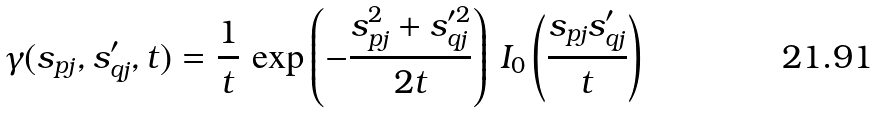Convert formula to latex. <formula><loc_0><loc_0><loc_500><loc_500>\gamma ( s _ { p j } , s _ { q j } ^ { \prime } , t ) = \frac { 1 } { t } \, \exp \left ( - \frac { s _ { p j } ^ { 2 } + s _ { q j } ^ { \prime 2 } } { 2 t } \right ) \, I _ { 0 } \left ( \frac { s _ { p j } s _ { q j } ^ { \prime } } { t } \right )</formula> 